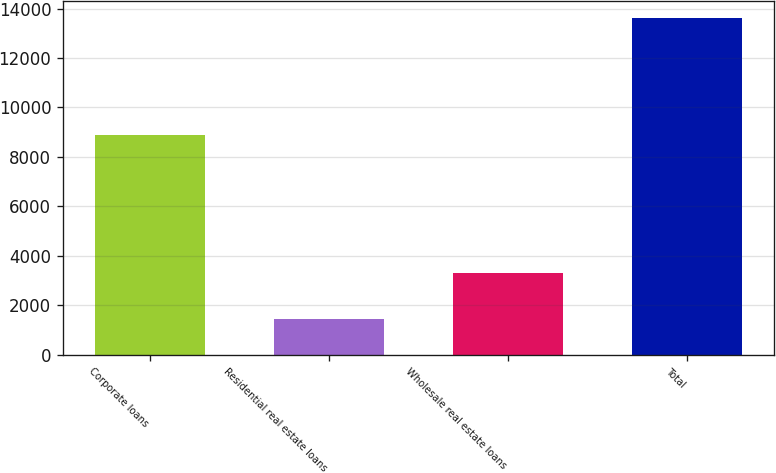Convert chart to OTSL. <chart><loc_0><loc_0><loc_500><loc_500><bar_chart><fcel>Corporate loans<fcel>Residential real estate loans<fcel>Wholesale real estate loans<fcel>Total<nl><fcel>8870<fcel>1447<fcel>3288<fcel>13605<nl></chart> 